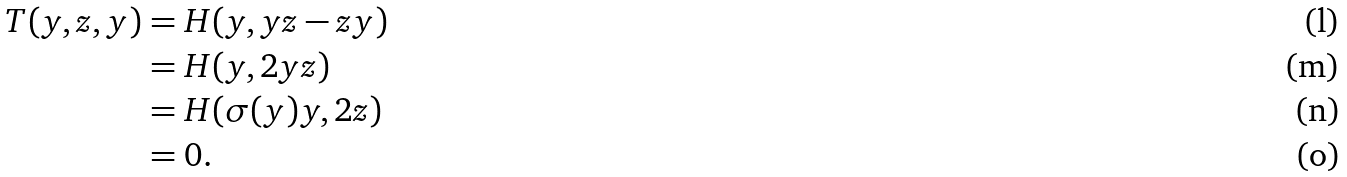<formula> <loc_0><loc_0><loc_500><loc_500>T ( y , z , y ) & = H ( y , y z - z y ) \\ & = H ( y , 2 y z ) \\ & = H ( \sigma ( y ) y , 2 z ) \\ & = 0 .</formula> 